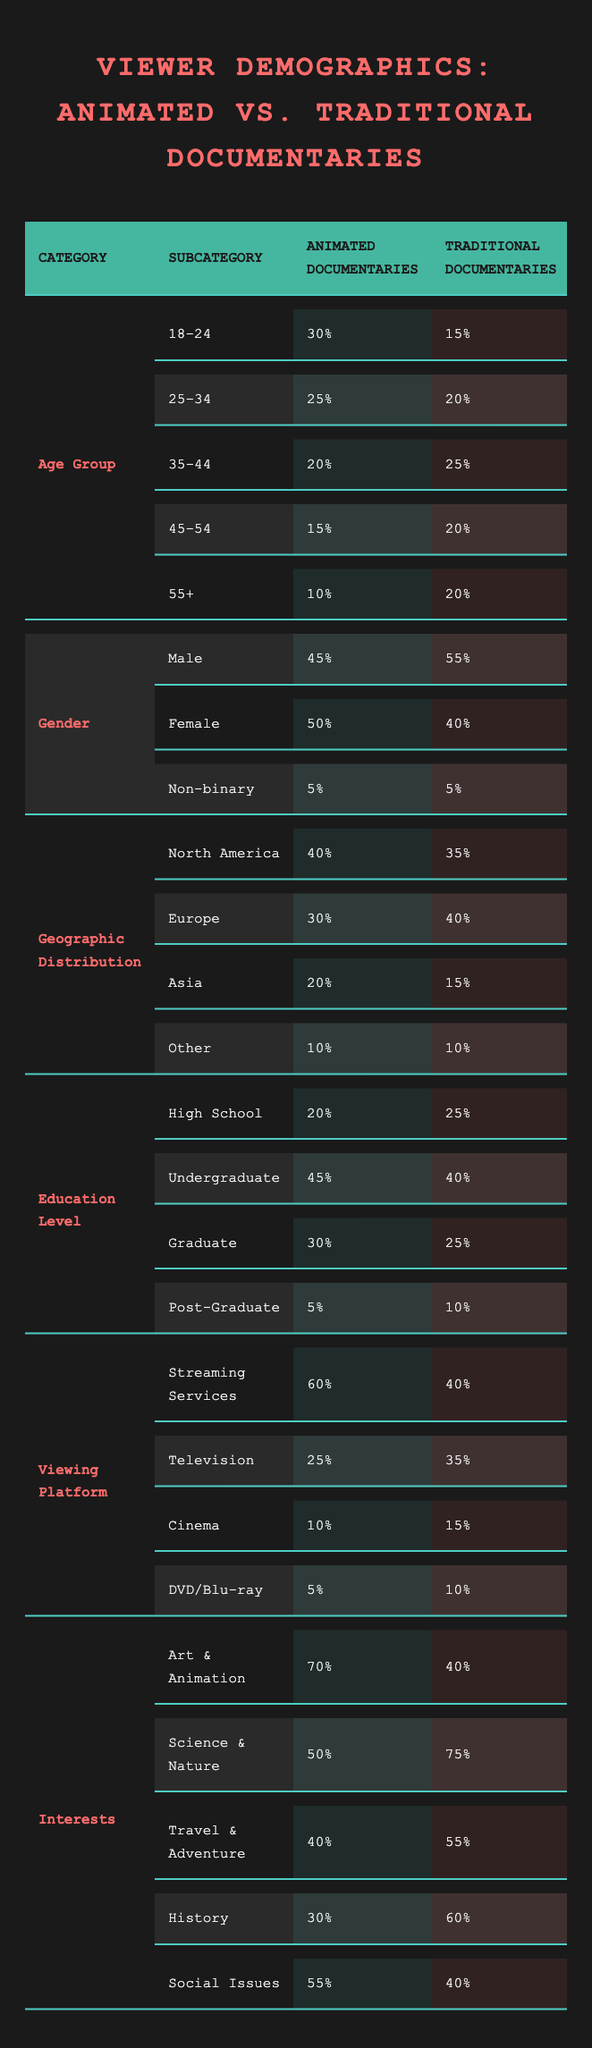What is the percentage of viewers aged 18-24 for animated documentaries? The table shows the age group distribution for animated documentaries, where 30% of viewers fall into the 18-24 age range.
Answer: 30% Which gender demographic has a higher percentage of viewers for traditional documentaries? The gender distribution shows that for traditional documentaries, 55% of viewers are male, compared to 45% for animated documentaries.
Answer: Male What percentage of viewers for animated documentaries are from Asia? The table reveals that 20% of the viewers for animated documentaries are from Asia.
Answer: 20% Is the percentage of male viewers higher for animated or traditional documentaries? The table indicates that 55% of traditional documentary viewers are male, whereas 45% of animated documentary viewers are male.
Answer: Traditional documentaries What is the difference in percentage of viewers interested in Art & Animation between animated and traditional documentaries? For animated documentaries, 70% are interested in Art & Animation, while for traditional documentaries, it is 40%. The difference is 70% - 40% = 30%.
Answer: 30% Which viewing platform has the highest percentage for animated documentaries? The data shows that 60% of animated documentary viewers prefer streaming services, the highest percentage in that category.
Answer: Streaming Services What is the total percentage of viewers aged 45 and older for traditional documentaries? For traditional documentaries, the percentages for age groups 45-54 and 55+ are 20% + 20% = 40%.
Answer: 40% How many more viewers are interested in Science & Nature for traditional documentaries compared to animated documentaries? The table states that 75% of traditional documentary viewers are interested in Science & Nature compared to 50% for animated documentaries. The difference is 75% - 50% = 25%.
Answer: 25% Which geographic region has a higher percentage of viewers for animated documentaries compared to traditional documentaries? The table shows that North America has 40% for animated documentaries and 35% for traditional documentaries, indicating it has a higher percentage for animated documentaries.
Answer: North America What is the total percentage of viewers with a high school education level or lower for both types of documentaries? For animated documentaries, 20% are high school educated, and for traditional documentaries, 25% are high school educated. The total for both is 20% + 25% = 45%.
Answer: 45% 